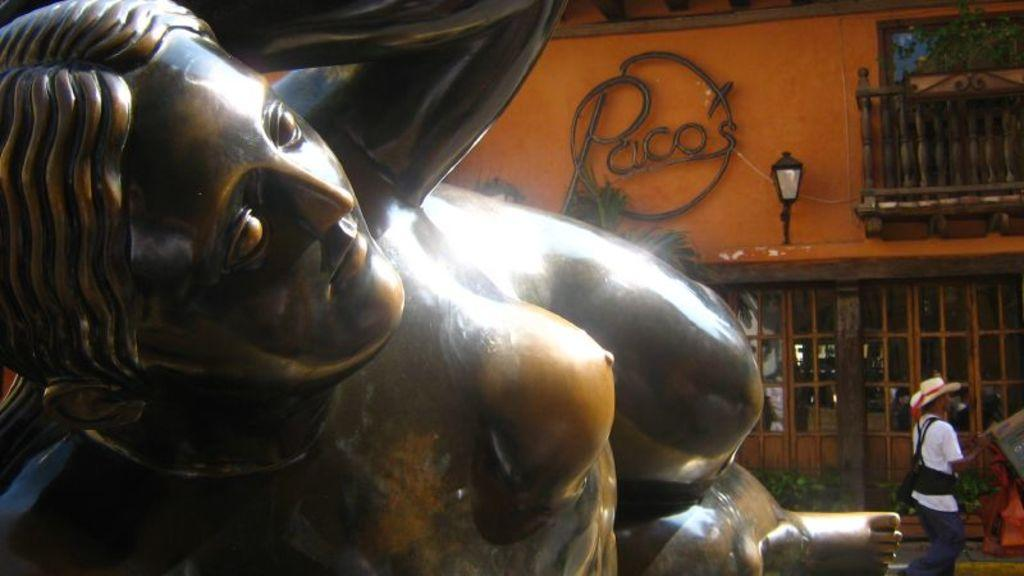What is the main subject in the image? There is a statue in the image. What can be seen in the background of the image? There is a shop in the background of the image. What is located in front of the shop? There is a road in front of the shop. What is the person in the image doing? A person is walking on the road. What type of pollution can be seen coming from the statue in the image? There is no pollution visible in the image, and the statue is not emitting any pollutants. 